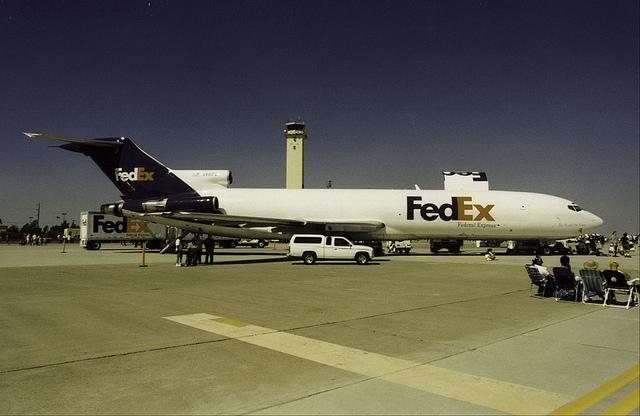What 16 letter word is on the plane?
Be succinct. Federal express. How many people are sitting in lawn chairs?
Short answer required. 4. What is painted on the front of this plane?
Be succinct. Fedex. Are these passenger planes?
Concise answer only. No. What letters are on the plane's tail?
Quick response, please. Fedex. What is written on the plane?
Quick response, please. Fedex. What airport is this?
Quick response, please. Fedex. How many people are shown?
Give a very brief answer. 2. What airline is on the side of the plane?
Concise answer only. Fedex. How many stars are on the plane?
Answer briefly. 0. What type of plane are these?
Concise answer only. Fedex. What delivery company does this plane belong to?
Answer briefly. Fedex. What airline is this plane?
Answer briefly. Fedex. Is the day clear?
Write a very short answer. Yes. Has it been raining?
Be succinct. No. What is the color scheme of the plane?
Answer briefly. White. What airline is this plane flying for?
Short answer required. Fedex. Where is the truck that has the lights on?
Be succinct. By plane. What color is the truck?
Be succinct. White. What type of photo is  this?
Be succinct. Color. What color is the top of the plane?
Short answer required. White. What type of plane is this?
Give a very brief answer. Fedex. What type of planes are in the photo?
Concise answer only. Fedex. What time was it when the photo was taken?
Give a very brief answer. Daytime. Is this an air force base?
Be succinct. No. 